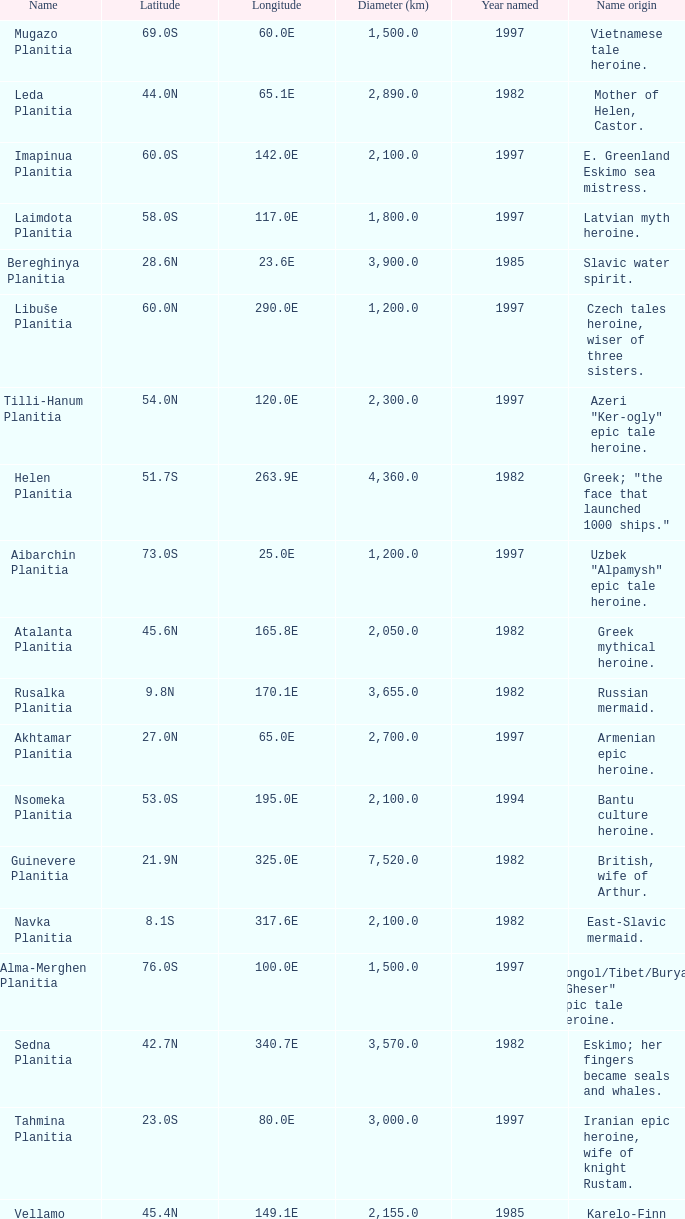What is the diameter (km) of the feature of latitude 23.0s 3000.0. 